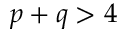Convert formula to latex. <formula><loc_0><loc_0><loc_500><loc_500>p + q > 4</formula> 